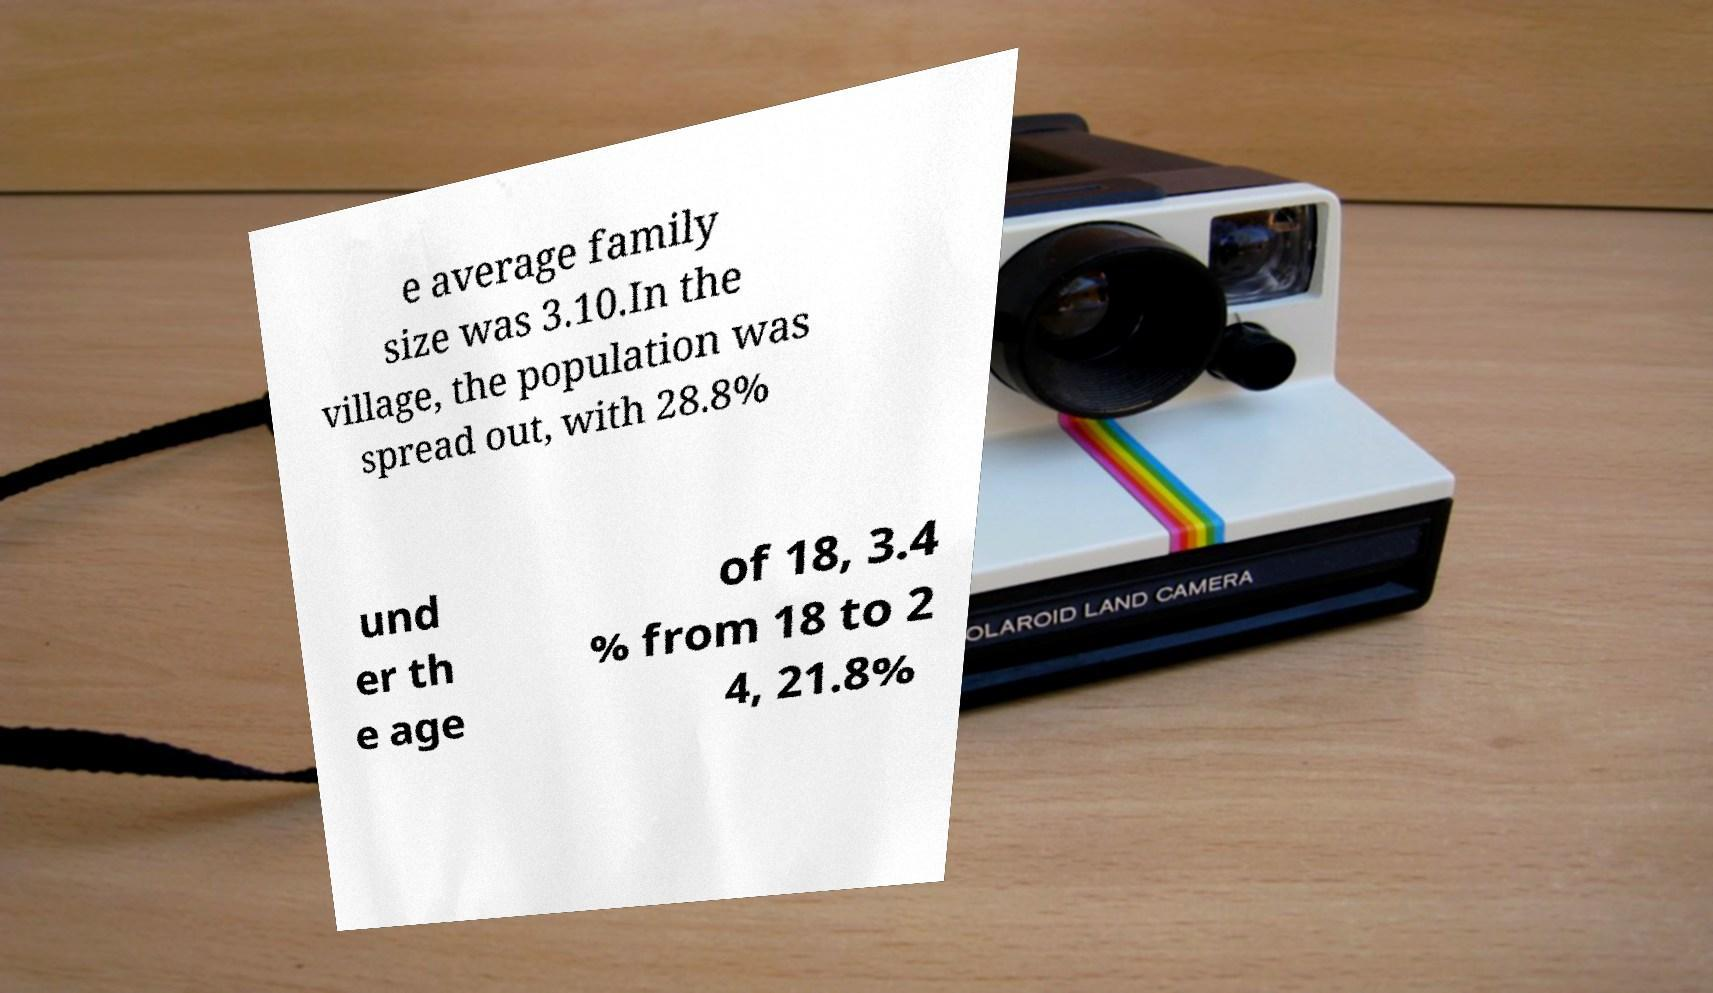Please identify and transcribe the text found in this image. e average family size was 3.10.In the village, the population was spread out, with 28.8% und er th e age of 18, 3.4 % from 18 to 2 4, 21.8% 